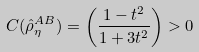Convert formula to latex. <formula><loc_0><loc_0><loc_500><loc_500>C ( \hat { \rho } _ { \eta } ^ { A B } ) = \left ( \frac { 1 - t ^ { 2 } } { 1 + 3 t ^ { 2 } } \right ) > 0</formula> 